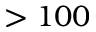<formula> <loc_0><loc_0><loc_500><loc_500>> 1 0 0</formula> 